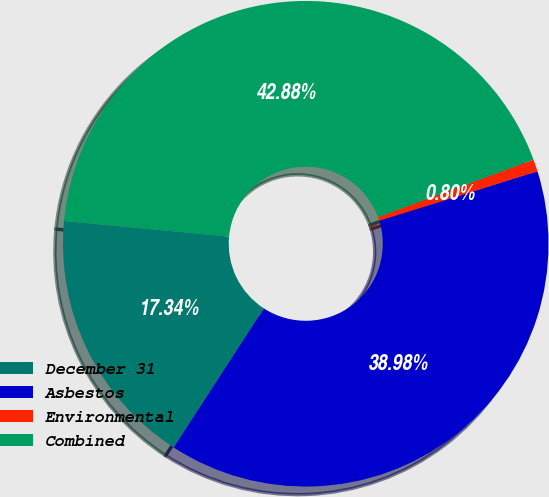Convert chart to OTSL. <chart><loc_0><loc_0><loc_500><loc_500><pie_chart><fcel>December 31<fcel>Asbestos<fcel>Environmental<fcel>Combined<nl><fcel>17.34%<fcel>38.98%<fcel>0.8%<fcel>42.88%<nl></chart> 